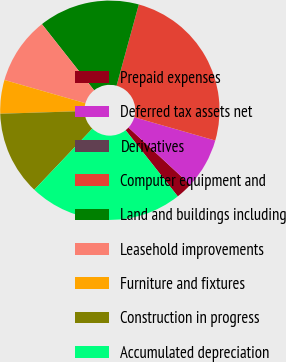Convert chart to OTSL. <chart><loc_0><loc_0><loc_500><loc_500><pie_chart><fcel>Prepaid expenses<fcel>Deferred tax assets net<fcel>Derivatives<fcel>Computer equipment and<fcel>Land and buildings including<fcel>Leasehold improvements<fcel>Furniture and fixtures<fcel>Construction in progress<fcel>Accumulated depreciation<nl><fcel>2.48%<fcel>7.44%<fcel>0.0%<fcel>25.2%<fcel>14.88%<fcel>9.92%<fcel>4.96%<fcel>12.4%<fcel>22.72%<nl></chart> 